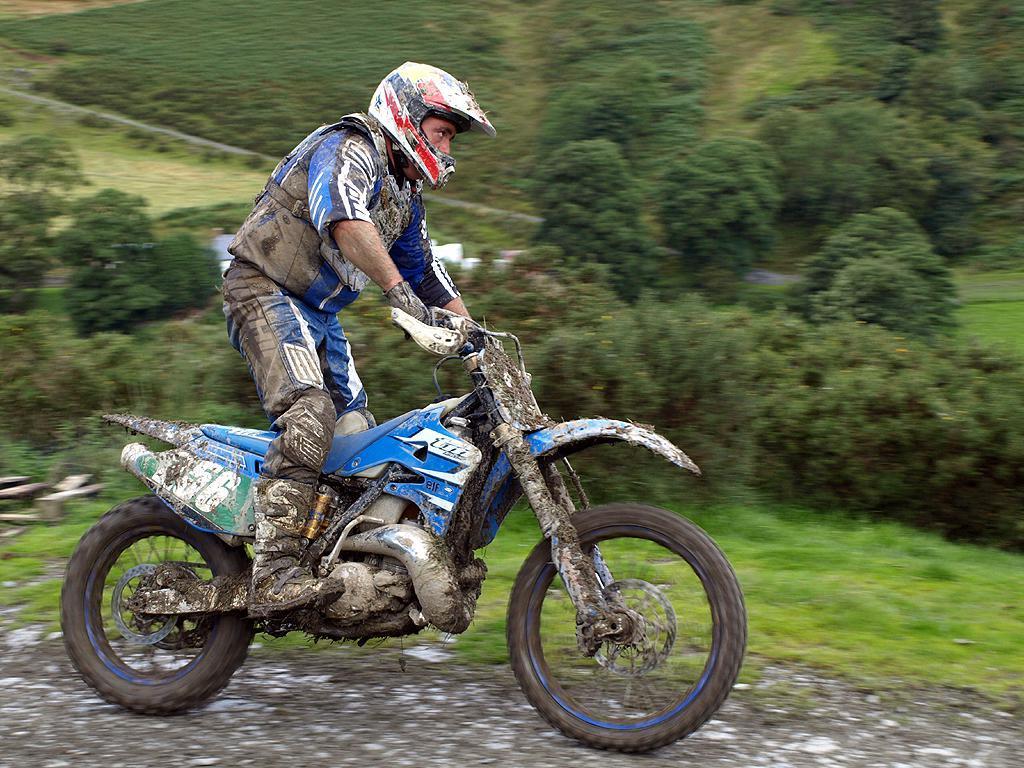Please provide a concise description of this image. In this image we can see a person riding on the bike, there are plants, trees, and the grass. 